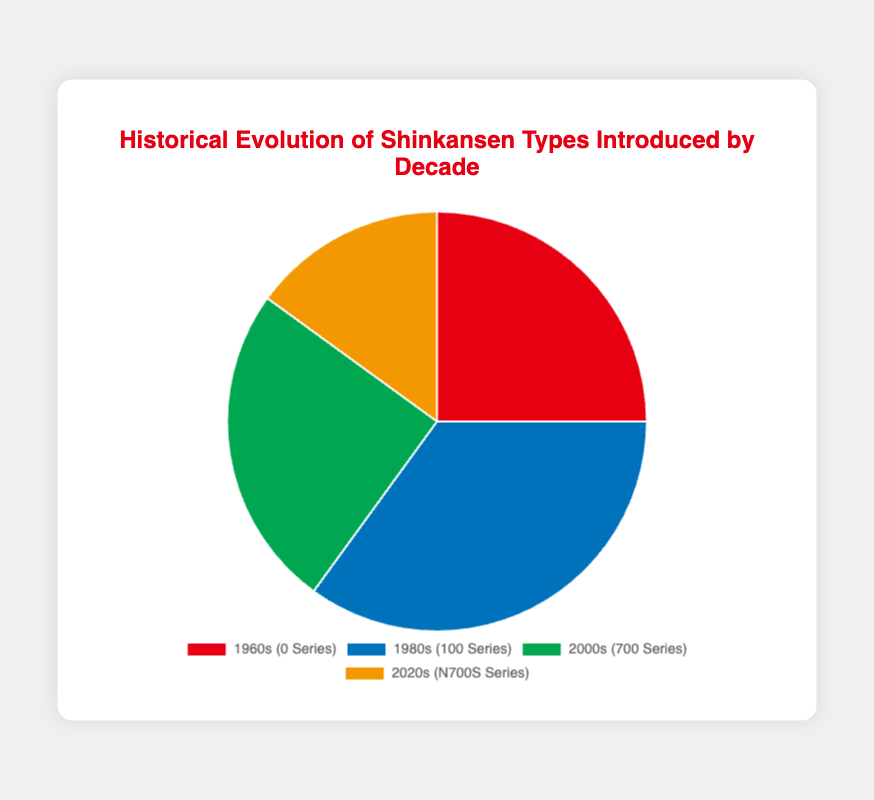What percentage of Shinkansen types were introduced in the 1980s? By looking at the pie chart, we can see the blue section corresponds to the percentage introduced in the 1980s. The legend indicates this percentage is 35%.
Answer: 35% Which decade had the second highest percentage of Shinkansen types introduced? By comparing the sections of the pie chart, the 1980s had the highest at 35%, followed by the 1960s and 2000s both at 25%.
Answer: 1960s and 2000s What is the total percentage of Shinkansen types introduced during the 20th century? Adding the percentages for the 1960s and 1980s, as they fall within the 20th century, is 25% + 35% = 60%.
Answer: 60% How does the percentage of Shinkansen types introduced in the 2020s compare to that in the 1960s? The 2020s (15%) have a lower percentage than the 1960s (25%).
Answer: Lower What is the difference in the percentage of Shinkansen types introduced between the decade with the highest percentage and the decade with the lowest percentage? The decade with the highest percentage is the 1980s (35%), and the lowest is the 2020s (15%). The difference is 35% - 15% = 20%.
Answer: 20% What share of the total do the Shinkansen types introduced in the 2000s make up? The pie chart shows the 2000s at 25%. This means 25% of the total Shinkansen types were introduced in this decade.
Answer: 25% If you combine the percentage of Shinkansen types introduced in the 1960s and 2000s, what fraction of the types does it represent? The combined percentage is 25% + 25% = 50%. This represents 50/100, which simplifies to the fraction 1/2.
Answer: 1/2 What color represents the Shinkansen types introduced in the 1980s on the pie chart? The chart legend indicates that the 1980s are represented by the color blue.
Answer: Blue Which decade is represented by the smallest section of the pie chart? Observing the pie chart, the smallest section is for the 2020s, which has the smallest percentage of 15%.
Answer: 2020s If a new Shinkansen type is introduced in the 2030s, and it occupies 10% of the pie chart, what percentage of the pie will be occupied by other decades? If the 2030s occupy 10%, the remaining will be 100% - 10% = 90%.
Answer: 90% 